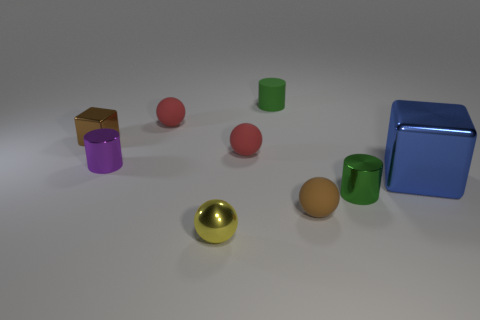Do the metal cube that is in front of the tiny purple cylinder and the small shiny object that is to the right of the small shiny ball have the same color?
Give a very brief answer. No. Are there fewer metal cylinders right of the large metal object than blocks that are left of the tiny yellow sphere?
Make the answer very short. Yes. What color is the other shiny thing that is the same shape as the purple metallic thing?
Provide a short and direct response. Green. There is a yellow metal object; does it have the same shape as the brown object in front of the large blue block?
Offer a terse response. Yes. How many objects are either tiny brown objects that are in front of the tiny brown metallic block or cylinders that are to the left of the metal ball?
Offer a terse response. 2. What is the material of the big blue thing?
Ensure brevity in your answer.  Metal. What number of other things are the same size as the green shiny cylinder?
Provide a succinct answer. 7. What size is the cube that is on the left side of the tiny yellow thing?
Give a very brief answer. Small. What is the thing that is on the right side of the green object that is on the right side of the tiny brown object that is to the right of the tiny brown shiny thing made of?
Offer a very short reply. Metal. Does the small purple metal object have the same shape as the blue object?
Your answer should be compact. No. 